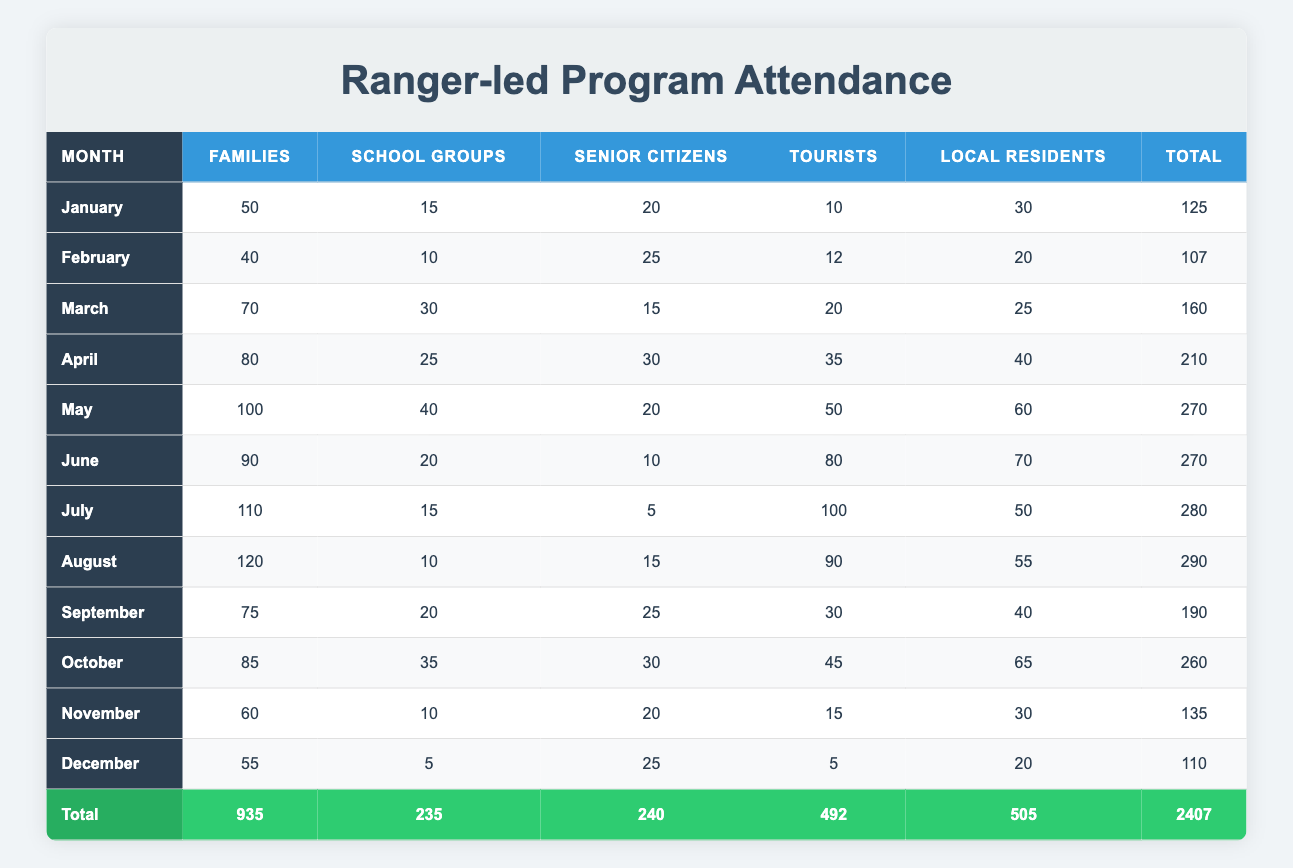What was the attendance in July for School Groups? Looking at the row for July under the School Groups column, the attendance value is 15.
Answer: 15 Which month had the highest attendance for Families? By examining the Families column, the highest Attendance value is 120 in August.
Answer: August What is the total attendance for Local Residents across all months? To find this, we sum the Local Residents column: 30 + 20 + 25 + 40 + 60 + 70 + 50 + 55 + 40 + 65 + 30 + 20 = 505.
Answer: 505 Did more Senior Citizens attend programs in March than in November? Comparing the Senior Citizens values, March has 15 attendees, while November has 20. Since 15 is less than 20, the answer is no.
Answer: No What was the average attendance for Tourists during the summer months (June, July, August)? The summer months have the following Tourist attendances: June (80), July (100), August (90). The sum is 80 + 100 + 90 = 270. The average is then 270 divided by 3, which equals 90.
Answer: 90 Which month had the lowest overall attendance? The total attendance values per month are: January (125), February (107), March (160), April (210), May (270), June (270), July (280), August (290), September (190), October (260), November (135), December (110). The minimum total is in February with 107.
Answer: February In what month did Local Residents have the highest attendance? Checking the Local Residents column, the highest attendance is 70 in June.
Answer: June How does the attendance of School Groups in April compare to the attendance of Families in the same month? In April, the School Groups had 25 attendees while Families had 80. Since 80 is greater than 25, Families had more attendance.
Answer: Families had more attendance What is the combined attendance of Families and Tourists in October? The attendance values in October are: Families (85) and Tourists (45). Their combined attendance is 85 + 45 = 130.
Answer: 130 